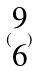Convert formula to latex. <formula><loc_0><loc_0><loc_500><loc_500>( \begin{matrix} 9 \\ 6 \end{matrix} )</formula> 